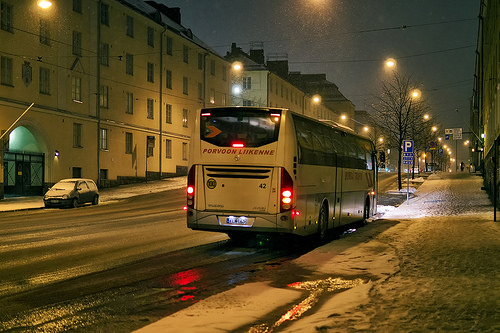<image>
Is the bus in the road? Yes. The bus is contained within or inside the road, showing a containment relationship. 